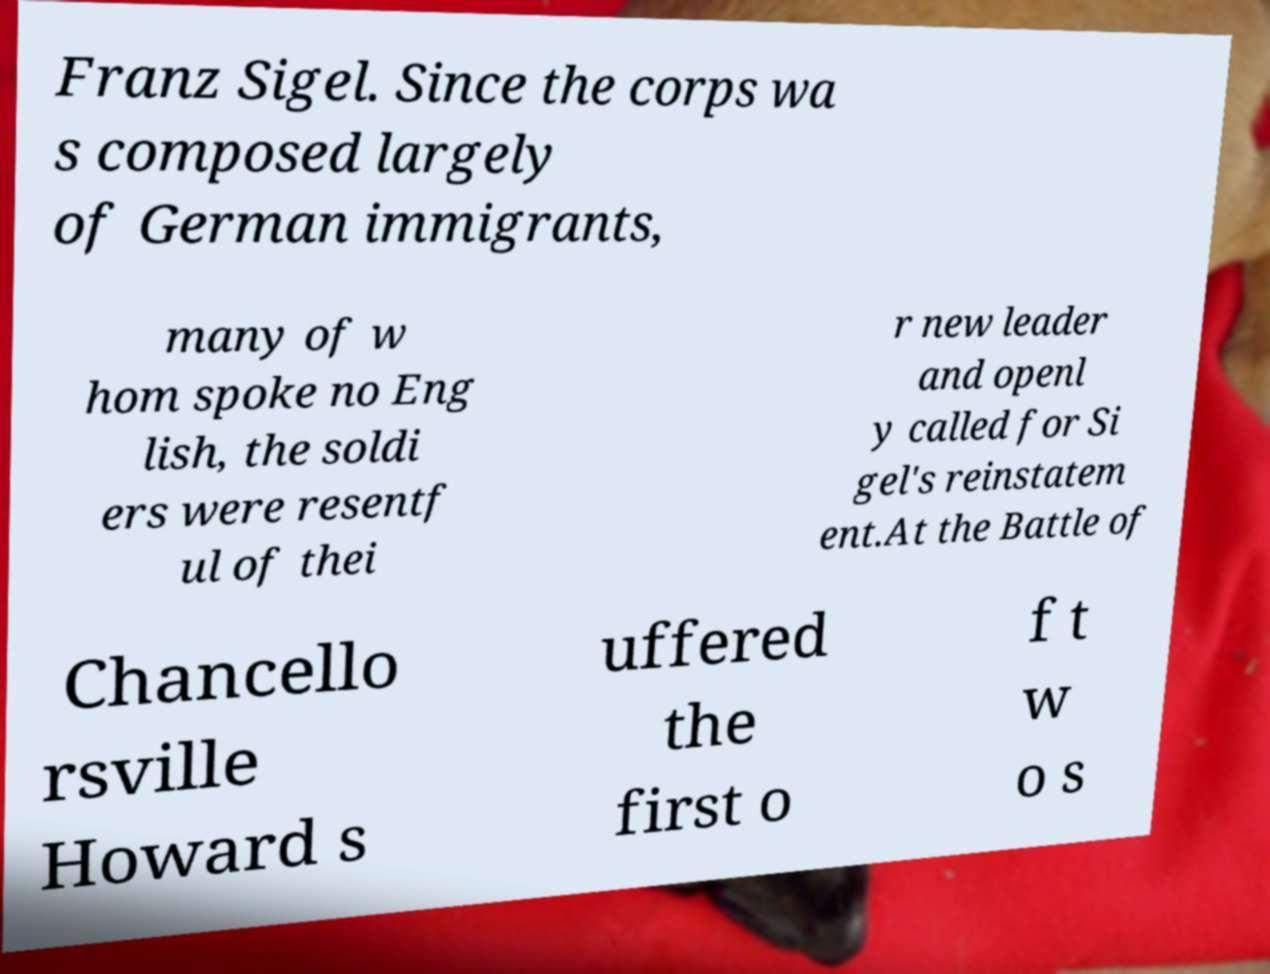Please identify and transcribe the text found in this image. Franz Sigel. Since the corps wa s composed largely of German immigrants, many of w hom spoke no Eng lish, the soldi ers were resentf ul of thei r new leader and openl y called for Si gel's reinstatem ent.At the Battle of Chancello rsville Howard s uffered the first o f t w o s 